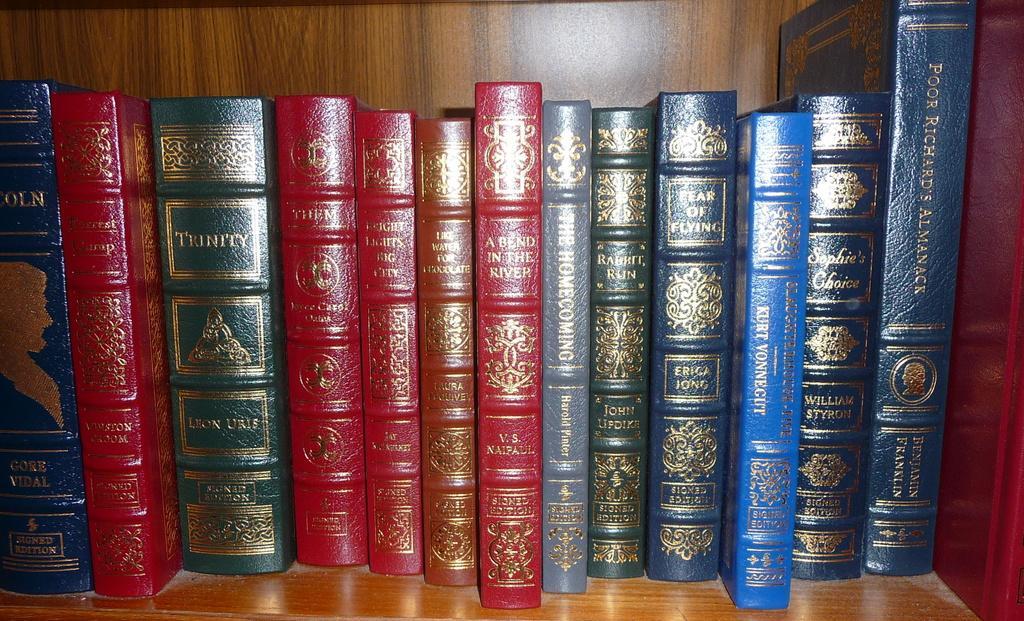Could you give a brief overview of what you see in this image? In the image we can see there are many books, kept on the shelf. The books are in different colors. 